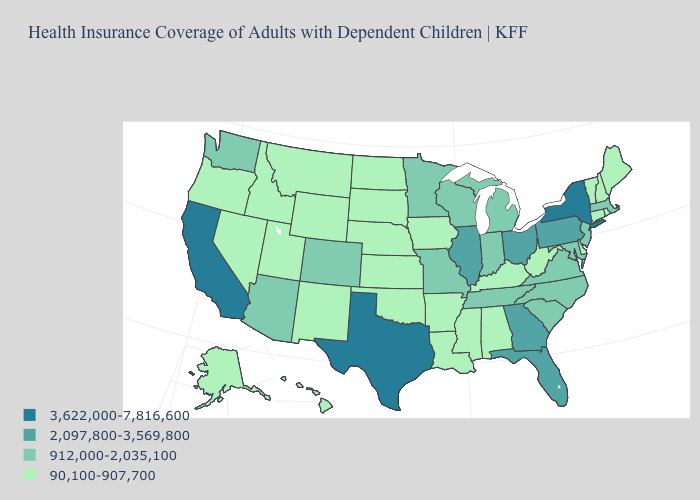Which states have the highest value in the USA?
Write a very short answer. California, New York, Texas. How many symbols are there in the legend?
Answer briefly. 4. What is the lowest value in the USA?
Answer briefly. 90,100-907,700. Is the legend a continuous bar?
Answer briefly. No. What is the lowest value in the West?
Give a very brief answer. 90,100-907,700. What is the value of Florida?
Quick response, please. 2,097,800-3,569,800. What is the lowest value in the USA?
Give a very brief answer. 90,100-907,700. Which states have the highest value in the USA?
Write a very short answer. California, New York, Texas. Name the states that have a value in the range 90,100-907,700?
Concise answer only. Alabama, Alaska, Arkansas, Connecticut, Delaware, Hawaii, Idaho, Iowa, Kansas, Kentucky, Louisiana, Maine, Mississippi, Montana, Nebraska, Nevada, New Hampshire, New Mexico, North Dakota, Oklahoma, Oregon, Rhode Island, South Dakota, Utah, Vermont, West Virginia, Wyoming. Is the legend a continuous bar?
Keep it brief. No. How many symbols are there in the legend?
Give a very brief answer. 4. Does the map have missing data?
Keep it brief. No. Which states have the highest value in the USA?
Be succinct. California, New York, Texas. Name the states that have a value in the range 2,097,800-3,569,800?
Answer briefly. Florida, Georgia, Illinois, Ohio, Pennsylvania. Among the states that border New Jersey , does Delaware have the lowest value?
Keep it brief. Yes. 